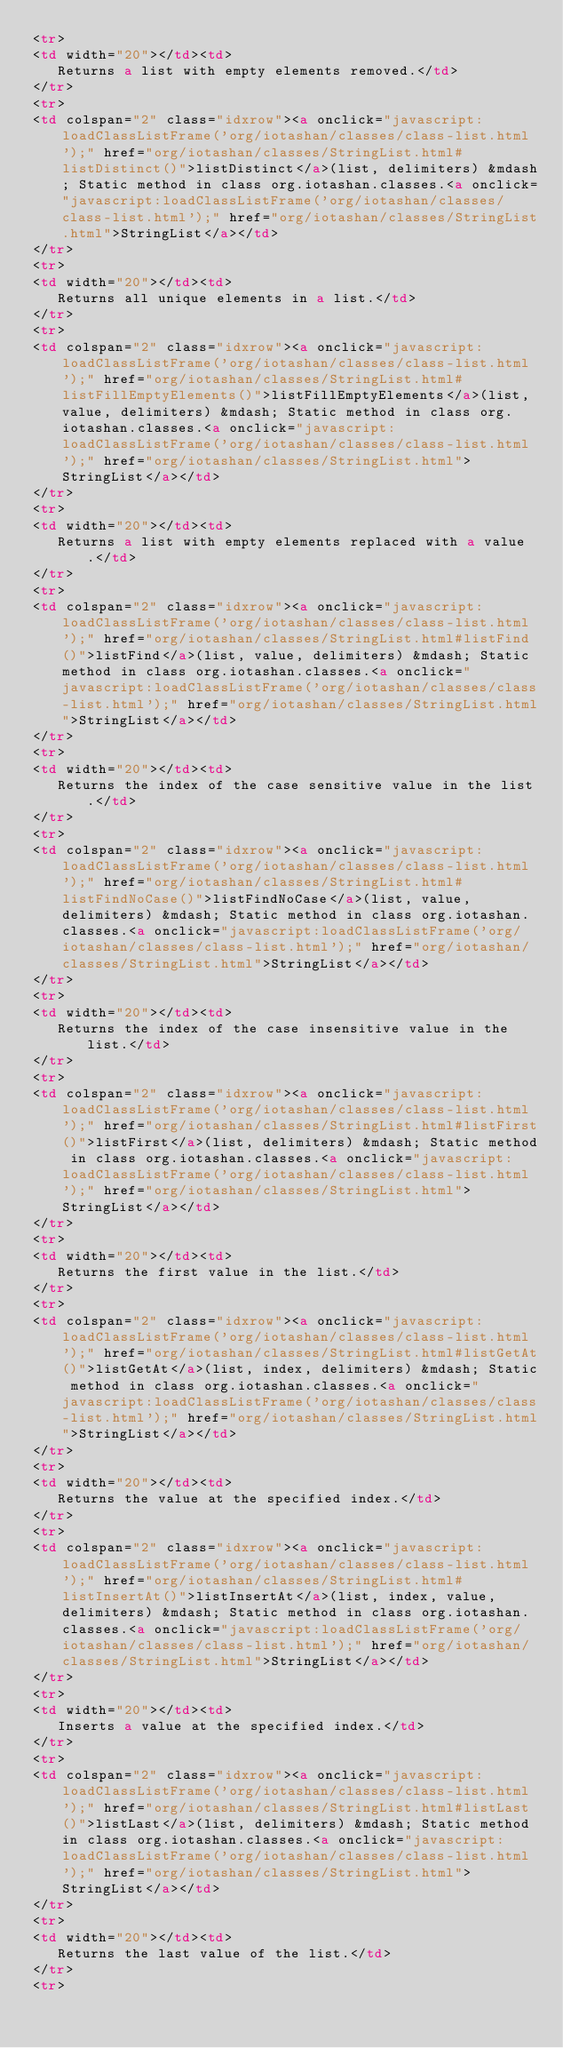<code> <loc_0><loc_0><loc_500><loc_500><_HTML_><tr>
<td width="20"></td><td>
   Returns a list with empty elements removed.</td>
</tr>
<tr>
<td colspan="2" class="idxrow"><a onclick="javascript:loadClassListFrame('org/iotashan/classes/class-list.html');" href="org/iotashan/classes/StringList.html#listDistinct()">listDistinct</a>(list, delimiters) &mdash; Static method in class org.iotashan.classes.<a onclick="javascript:loadClassListFrame('org/iotashan/classes/class-list.html');" href="org/iotashan/classes/StringList.html">StringList</a></td>
</tr>
<tr>
<td width="20"></td><td>
   Returns all unique elements in a list.</td>
</tr>
<tr>
<td colspan="2" class="idxrow"><a onclick="javascript:loadClassListFrame('org/iotashan/classes/class-list.html');" href="org/iotashan/classes/StringList.html#listFillEmptyElements()">listFillEmptyElements</a>(list, value, delimiters) &mdash; Static method in class org.iotashan.classes.<a onclick="javascript:loadClassListFrame('org/iotashan/classes/class-list.html');" href="org/iotashan/classes/StringList.html">StringList</a></td>
</tr>
<tr>
<td width="20"></td><td>
   Returns a list with empty elements replaced with a value.</td>
</tr>
<tr>
<td colspan="2" class="idxrow"><a onclick="javascript:loadClassListFrame('org/iotashan/classes/class-list.html');" href="org/iotashan/classes/StringList.html#listFind()">listFind</a>(list, value, delimiters) &mdash; Static method in class org.iotashan.classes.<a onclick="javascript:loadClassListFrame('org/iotashan/classes/class-list.html');" href="org/iotashan/classes/StringList.html">StringList</a></td>
</tr>
<tr>
<td width="20"></td><td>
   Returns the index of the case sensitive value in the list.</td>
</tr>
<tr>
<td colspan="2" class="idxrow"><a onclick="javascript:loadClassListFrame('org/iotashan/classes/class-list.html');" href="org/iotashan/classes/StringList.html#listFindNoCase()">listFindNoCase</a>(list, value, delimiters) &mdash; Static method in class org.iotashan.classes.<a onclick="javascript:loadClassListFrame('org/iotashan/classes/class-list.html');" href="org/iotashan/classes/StringList.html">StringList</a></td>
</tr>
<tr>
<td width="20"></td><td>
   Returns the index of the case insensitive value in the list.</td>
</tr>
<tr>
<td colspan="2" class="idxrow"><a onclick="javascript:loadClassListFrame('org/iotashan/classes/class-list.html');" href="org/iotashan/classes/StringList.html#listFirst()">listFirst</a>(list, delimiters) &mdash; Static method in class org.iotashan.classes.<a onclick="javascript:loadClassListFrame('org/iotashan/classes/class-list.html');" href="org/iotashan/classes/StringList.html">StringList</a></td>
</tr>
<tr>
<td width="20"></td><td>
   Returns the first value in the list.</td>
</tr>
<tr>
<td colspan="2" class="idxrow"><a onclick="javascript:loadClassListFrame('org/iotashan/classes/class-list.html');" href="org/iotashan/classes/StringList.html#listGetAt()">listGetAt</a>(list, index, delimiters) &mdash; Static method in class org.iotashan.classes.<a onclick="javascript:loadClassListFrame('org/iotashan/classes/class-list.html');" href="org/iotashan/classes/StringList.html">StringList</a></td>
</tr>
<tr>
<td width="20"></td><td>
   Returns the value at the specified index.</td>
</tr>
<tr>
<td colspan="2" class="idxrow"><a onclick="javascript:loadClassListFrame('org/iotashan/classes/class-list.html');" href="org/iotashan/classes/StringList.html#listInsertAt()">listInsertAt</a>(list, index, value, delimiters) &mdash; Static method in class org.iotashan.classes.<a onclick="javascript:loadClassListFrame('org/iotashan/classes/class-list.html');" href="org/iotashan/classes/StringList.html">StringList</a></td>
</tr>
<tr>
<td width="20"></td><td>
   Inserts a value at the specified index.</td>
</tr>
<tr>
<td colspan="2" class="idxrow"><a onclick="javascript:loadClassListFrame('org/iotashan/classes/class-list.html');" href="org/iotashan/classes/StringList.html#listLast()">listLast</a>(list, delimiters) &mdash; Static method in class org.iotashan.classes.<a onclick="javascript:loadClassListFrame('org/iotashan/classes/class-list.html');" href="org/iotashan/classes/StringList.html">StringList</a></td>
</tr>
<tr>
<td width="20"></td><td>
   Returns the last value of the list.</td>
</tr>
<tr></code> 